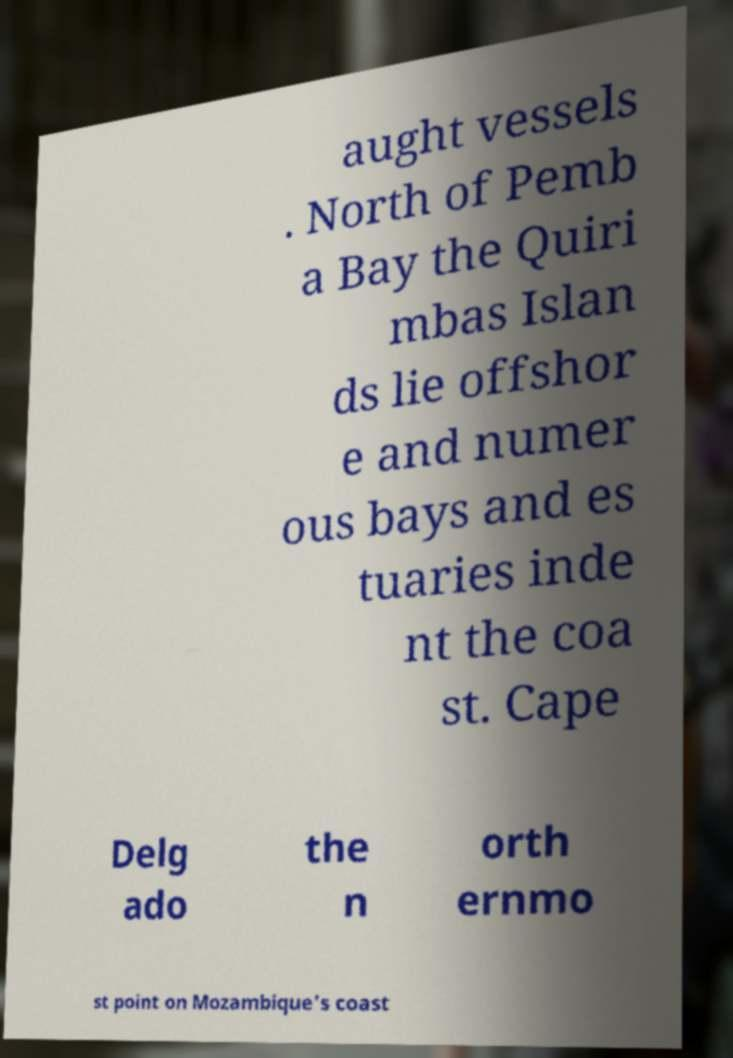Could you extract and type out the text from this image? aught vessels . North of Pemb a Bay the Quiri mbas Islan ds lie offshor e and numer ous bays and es tuaries inde nt the coa st. Cape Delg ado the n orth ernmo st point on Mozambique's coast 